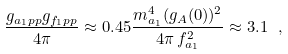Convert formula to latex. <formula><loc_0><loc_0><loc_500><loc_500>\frac { g _ { a _ { 1 } p p } g _ { f _ { 1 } p p } } { 4 \pi } \approx 0 . 4 5 \frac { m ^ { 4 } _ { a _ { 1 } } ( g _ { A } ( 0 ) ) ^ { 2 } } { 4 \pi \, f ^ { 2 } _ { a _ { 1 } } } \approx 3 . 1 \ ,</formula> 